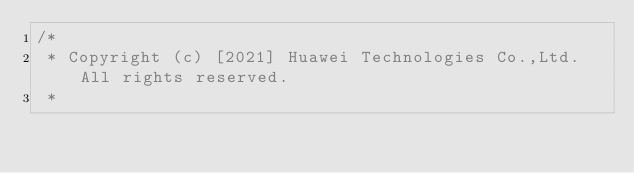Convert code to text. <code><loc_0><loc_0><loc_500><loc_500><_Java_>/*
 * Copyright (c) [2021] Huawei Technologies Co.,Ltd.All rights reserved.
 *</code> 